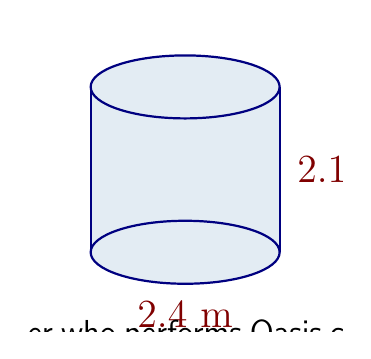Solve this math problem. Let's approach this step-by-step:

1) The formula for the volume of a cylinder is:

   $$V = \pi r^2 h$$

   where $r$ is the radius and $h$ is the height.

2) We're given the diameter (2.4 m) and height (2.1 m). We need to find the radius:

   $$r = \frac{\text{diameter}}{2} = \frac{2.4}{2} = 1.2 \text{ m}$$

3) Now we can plug these values into our formula:

   $$V = \pi (1.2 \text{ m})^2 (2.1 \text{ m})$$

4) Let's calculate:

   $$V = \pi (1.44 \text{ m}^2) (2.1 \text{ m})$$
   $$V = 3.0144\pi \text{ m}^3$$

5) Using 3.14159 as an approximation for $\pi$:

   $$V \approx 3.0144 \times 3.14159 \text{ m}^3 \approx 9.47 \text{ m}^3$$

6) Rounding to the nearest cubic meter:

   $$V \approx 9 \text{ m}^3$$
Answer: 9 m³ 